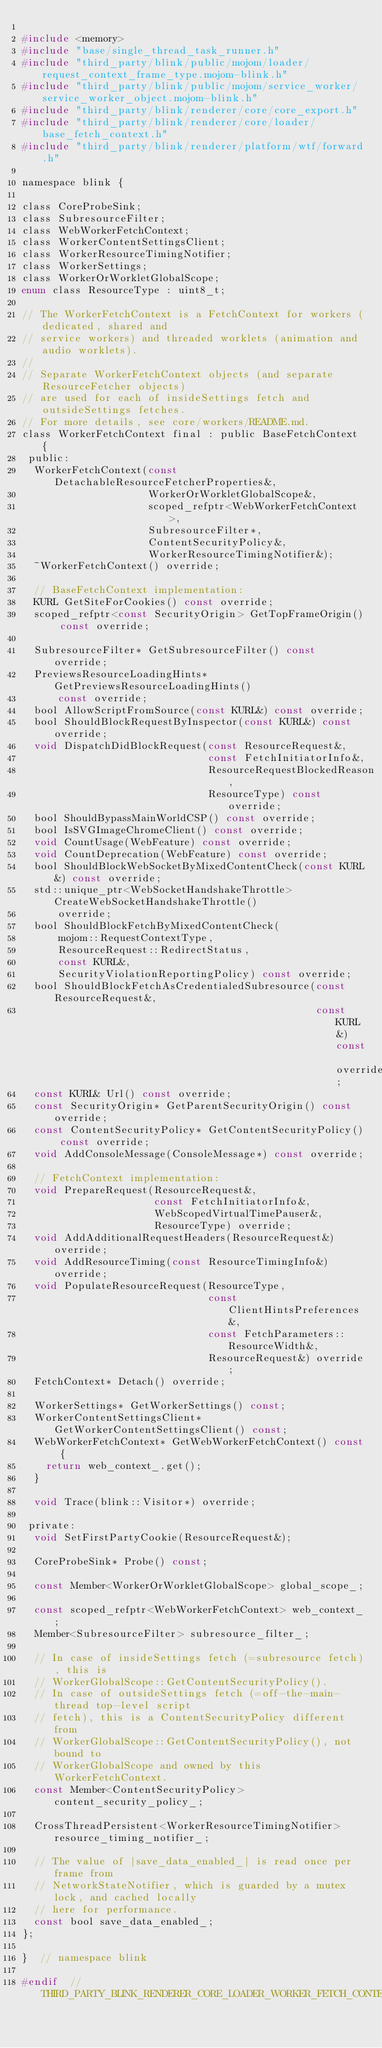<code> <loc_0><loc_0><loc_500><loc_500><_C_>
#include <memory>
#include "base/single_thread_task_runner.h"
#include "third_party/blink/public/mojom/loader/request_context_frame_type.mojom-blink.h"
#include "third_party/blink/public/mojom/service_worker/service_worker_object.mojom-blink.h"
#include "third_party/blink/renderer/core/core_export.h"
#include "third_party/blink/renderer/core/loader/base_fetch_context.h"
#include "third_party/blink/renderer/platform/wtf/forward.h"

namespace blink {

class CoreProbeSink;
class SubresourceFilter;
class WebWorkerFetchContext;
class WorkerContentSettingsClient;
class WorkerResourceTimingNotifier;
class WorkerSettings;
class WorkerOrWorkletGlobalScope;
enum class ResourceType : uint8_t;

// The WorkerFetchContext is a FetchContext for workers (dedicated, shared and
// service workers) and threaded worklets (animation and audio worklets).
//
// Separate WorkerFetchContext objects (and separate ResourceFetcher objects)
// are used for each of insideSettings fetch and outsideSettings fetches.
// For more details, see core/workers/README.md.
class WorkerFetchContext final : public BaseFetchContext {
 public:
  WorkerFetchContext(const DetachableResourceFetcherProperties&,
                     WorkerOrWorkletGlobalScope&,
                     scoped_refptr<WebWorkerFetchContext>,
                     SubresourceFilter*,
                     ContentSecurityPolicy&,
                     WorkerResourceTimingNotifier&);
  ~WorkerFetchContext() override;

  // BaseFetchContext implementation:
  KURL GetSiteForCookies() const override;
  scoped_refptr<const SecurityOrigin> GetTopFrameOrigin() const override;

  SubresourceFilter* GetSubresourceFilter() const override;
  PreviewsResourceLoadingHints* GetPreviewsResourceLoadingHints()
      const override;
  bool AllowScriptFromSource(const KURL&) const override;
  bool ShouldBlockRequestByInspector(const KURL&) const override;
  void DispatchDidBlockRequest(const ResourceRequest&,
                               const FetchInitiatorInfo&,
                               ResourceRequestBlockedReason,
                               ResourceType) const override;
  bool ShouldBypassMainWorldCSP() const override;
  bool IsSVGImageChromeClient() const override;
  void CountUsage(WebFeature) const override;
  void CountDeprecation(WebFeature) const override;
  bool ShouldBlockWebSocketByMixedContentCheck(const KURL&) const override;
  std::unique_ptr<WebSocketHandshakeThrottle> CreateWebSocketHandshakeThrottle()
      override;
  bool ShouldBlockFetchByMixedContentCheck(
      mojom::RequestContextType,
      ResourceRequest::RedirectStatus,
      const KURL&,
      SecurityViolationReportingPolicy) const override;
  bool ShouldBlockFetchAsCredentialedSubresource(const ResourceRequest&,
                                                 const KURL&) const override;
  const KURL& Url() const override;
  const SecurityOrigin* GetParentSecurityOrigin() const override;
  const ContentSecurityPolicy* GetContentSecurityPolicy() const override;
  void AddConsoleMessage(ConsoleMessage*) const override;

  // FetchContext implementation:
  void PrepareRequest(ResourceRequest&,
                      const FetchInitiatorInfo&,
                      WebScopedVirtualTimePauser&,
                      ResourceType) override;
  void AddAdditionalRequestHeaders(ResourceRequest&) override;
  void AddResourceTiming(const ResourceTimingInfo&) override;
  void PopulateResourceRequest(ResourceType,
                               const ClientHintsPreferences&,
                               const FetchParameters::ResourceWidth&,
                               ResourceRequest&) override;
  FetchContext* Detach() override;

  WorkerSettings* GetWorkerSettings() const;
  WorkerContentSettingsClient* GetWorkerContentSettingsClient() const;
  WebWorkerFetchContext* GetWebWorkerFetchContext() const {
    return web_context_.get();
  }

  void Trace(blink::Visitor*) override;

 private:
  void SetFirstPartyCookie(ResourceRequest&);

  CoreProbeSink* Probe() const;

  const Member<WorkerOrWorkletGlobalScope> global_scope_;

  const scoped_refptr<WebWorkerFetchContext> web_context_;
  Member<SubresourceFilter> subresource_filter_;

  // In case of insideSettings fetch (=subresource fetch), this is
  // WorkerGlobalScope::GetContentSecurityPolicy().
  // In case of outsideSettings fetch (=off-the-main-thread top-level script
  // fetch), this is a ContentSecurityPolicy different from
  // WorkerGlobalScope::GetContentSecurityPolicy(), not bound to
  // WorkerGlobalScope and owned by this WorkerFetchContext.
  const Member<ContentSecurityPolicy> content_security_policy_;

  CrossThreadPersistent<WorkerResourceTimingNotifier> resource_timing_notifier_;

  // The value of |save_data_enabled_| is read once per frame from
  // NetworkStateNotifier, which is guarded by a mutex lock, and cached locally
  // here for performance.
  const bool save_data_enabled_;
};

}  // namespace blink

#endif  // THIRD_PARTY_BLINK_RENDERER_CORE_LOADER_WORKER_FETCH_CONTEXT_H_
</code> 